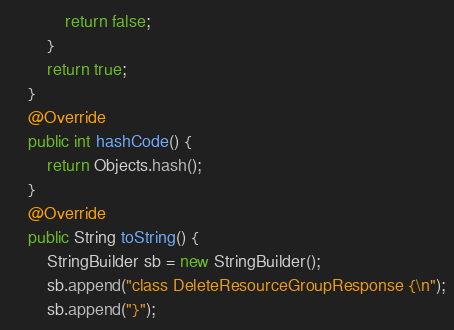<code> <loc_0><loc_0><loc_500><loc_500><_Java_>            return false;
        }
        return true;
    }
    @Override
    public int hashCode() {
        return Objects.hash();
    }
    @Override
    public String toString() {
        StringBuilder sb = new StringBuilder();
        sb.append("class DeleteResourceGroupResponse {\n");
        sb.append("}");</code> 